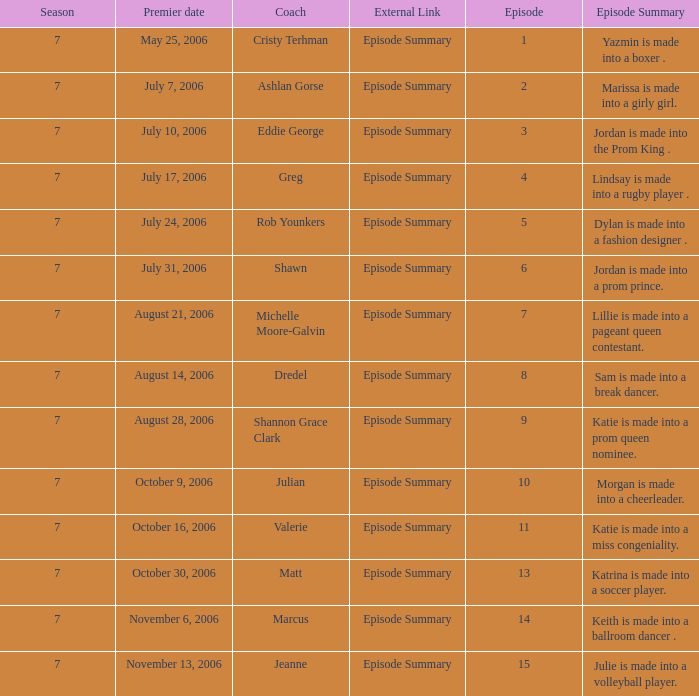How many episodes have Valerie? 1.0. 